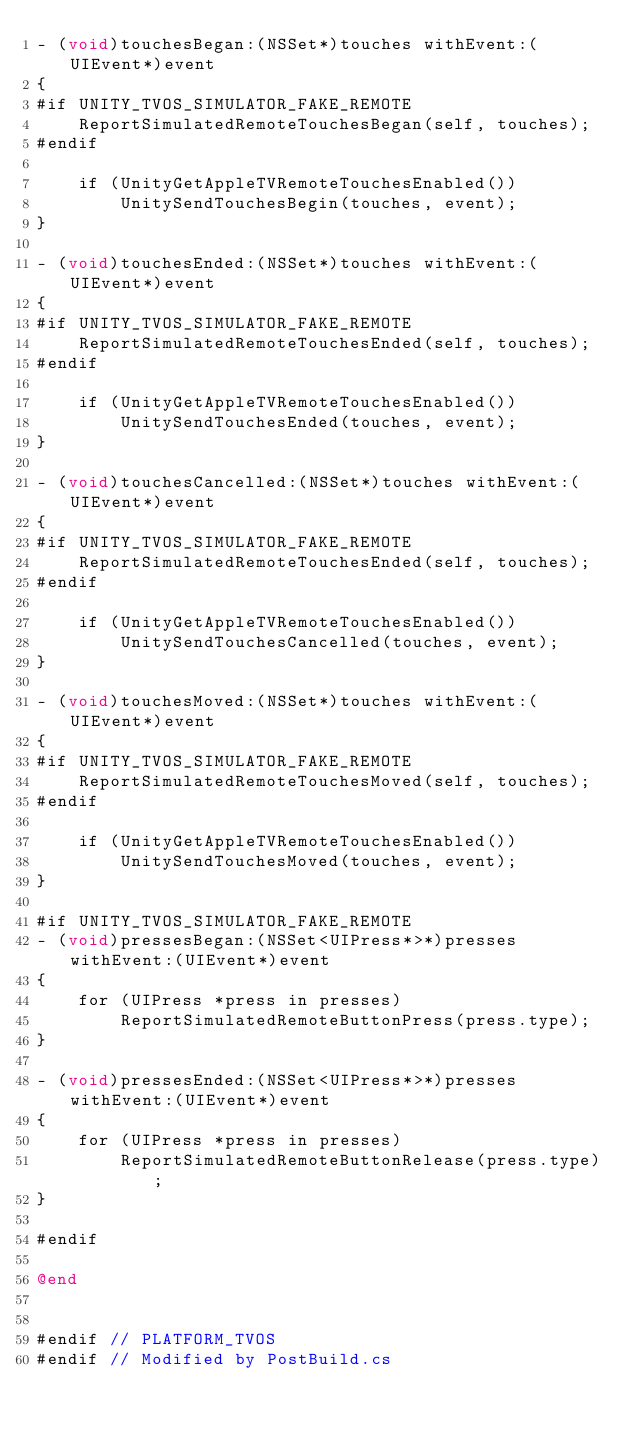<code> <loc_0><loc_0><loc_500><loc_500><_ObjectiveC_>- (void)touchesBegan:(NSSet*)touches withEvent:(UIEvent*)event
{
#if UNITY_TVOS_SIMULATOR_FAKE_REMOTE
    ReportSimulatedRemoteTouchesBegan(self, touches);
#endif

    if (UnityGetAppleTVRemoteTouchesEnabled())
        UnitySendTouchesBegin(touches, event);
}

- (void)touchesEnded:(NSSet*)touches withEvent:(UIEvent*)event
{
#if UNITY_TVOS_SIMULATOR_FAKE_REMOTE
    ReportSimulatedRemoteTouchesEnded(self, touches);
#endif

    if (UnityGetAppleTVRemoteTouchesEnabled())
        UnitySendTouchesEnded(touches, event);
}

- (void)touchesCancelled:(NSSet*)touches withEvent:(UIEvent*)event
{
#if UNITY_TVOS_SIMULATOR_FAKE_REMOTE
    ReportSimulatedRemoteTouchesEnded(self, touches);
#endif

    if (UnityGetAppleTVRemoteTouchesEnabled())
        UnitySendTouchesCancelled(touches, event);
}

- (void)touchesMoved:(NSSet*)touches withEvent:(UIEvent*)event
{
#if UNITY_TVOS_SIMULATOR_FAKE_REMOTE
    ReportSimulatedRemoteTouchesMoved(self, touches);
#endif

    if (UnityGetAppleTVRemoteTouchesEnabled())
        UnitySendTouchesMoved(touches, event);
}

#if UNITY_TVOS_SIMULATOR_FAKE_REMOTE
- (void)pressesBegan:(NSSet<UIPress*>*)presses withEvent:(UIEvent*)event
{
    for (UIPress *press in presses)
        ReportSimulatedRemoteButtonPress(press.type);
}

- (void)pressesEnded:(NSSet<UIPress*>*)presses withEvent:(UIEvent*)event
{
    for (UIPress *press in presses)
        ReportSimulatedRemoteButtonRelease(press.type);
}

#endif

@end


#endif // PLATFORM_TVOS
#endif // Modified by PostBuild.cs
</code> 